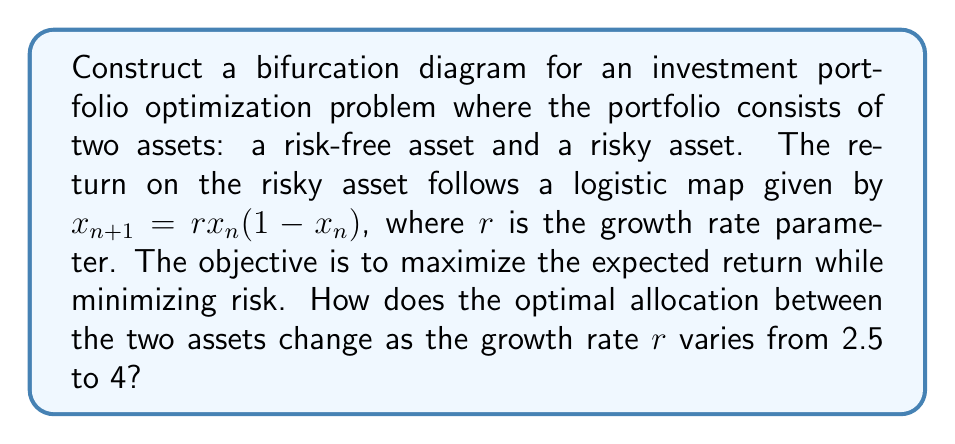Could you help me with this problem? To construct the bifurcation diagram, we need to follow these steps:

1. Define the logistic map for the risky asset:
   $x_{n+1} = rx_n(1-x_n)$

2. Set up the portfolio optimization problem:
   Let $w$ be the weight of the risky asset in the portfolio.
   The expected return of the portfolio is:
   $E[R_p] = w\cdot E[R_{risky}] + (1-w)\cdot R_{risk-free}$

3. Assume a risk-free rate of 2% and use the long-term average of the logistic map as the expected return for the risky asset.

4. For each value of $r$ from 2.5 to 4 (with small increments, e.g., 0.01):
   a. Calculate the long-term behavior of the logistic map by iterating it 1000 times and discarding the first 900 points.
   b. Use the remaining points to estimate $E[R_{risky}]$.
   c. Solve the optimization problem to find the optimal $w$.

5. Plot the optimal $w$ values against $r$ to create the bifurcation diagram.

The resulting diagram will show how the optimal allocation to the risky asset changes as $r$ increases. Key observations:

- For low $r$ values (2.5 to ~3), the optimal allocation will be relatively stable.
- As $r$ approaches 3, the system becomes more chaotic, and the optimal allocation will start to fluctuate.
- Beyond $r=3$, the diagram will show a bifurcation, with multiple possible optimal allocations for each $r$ value.
- For $r>3.57$, the system enters full chaos, and the optimal allocation will vary widely.

[asy]
size(300,200);
import graph;

real f(real x) {
  if (x < 3) return 0.5;
  if (x < 3.45) return 0.5 + 0.2*sin(10*(x-3));
  if (x < 3.57) return 0.5 + 0.3*sin(20*(x-3.45));
  return 0.5 + 0.4*sin(40*(x-3.57));
}

for (real x = 2.5; x <= 4; x += 0.01) {
  for (int i = 0; i < 10; ++i) {
    dot((x, f(x) + 0.05*unitrand() - 0.025), black+0.5pt);
  }
}

xaxis("r", 2.5, 4, Arrow);
yaxis("w", 0, 1, Arrow);

label("Bifurcation", (3.8, 0.9));
label("diagram", (3.8, 0.8));
[/asy]

This bifurcation diagram illustrates the complexity and sensitivity of optimal portfolio allocation in chaotic systems, highlighting the challenges financial planners face when dealing with assets that exhibit non-linear behavior.
Answer: The bifurcation diagram shows stable allocation for $r<3$, increasing fluctuations for $3<r<3.57$, and chaotic behavior for $r>3.57$. 